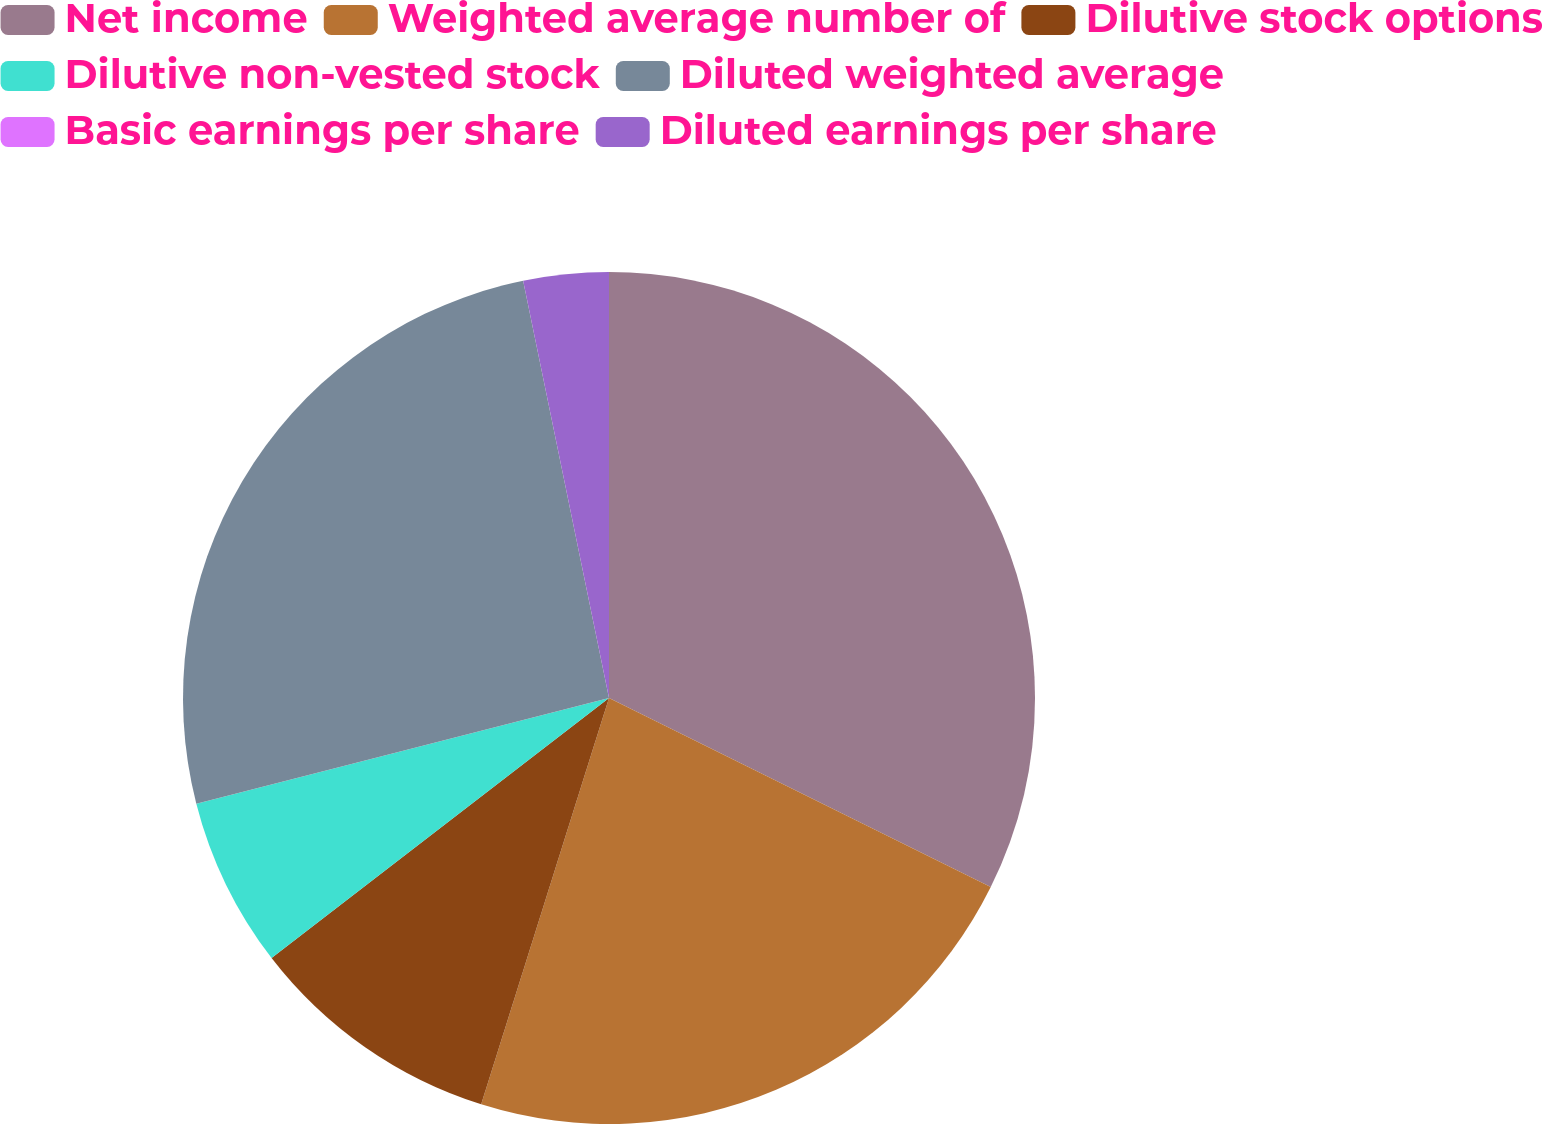<chart> <loc_0><loc_0><loc_500><loc_500><pie_chart><fcel>Net income<fcel>Weighted average number of<fcel>Dilutive stock options<fcel>Dilutive non-vested stock<fcel>Diluted weighted average<fcel>Basic earnings per share<fcel>Diluted earnings per share<nl><fcel>32.32%<fcel>22.53%<fcel>9.7%<fcel>6.46%<fcel>25.76%<fcel>0.0%<fcel>3.23%<nl></chart> 